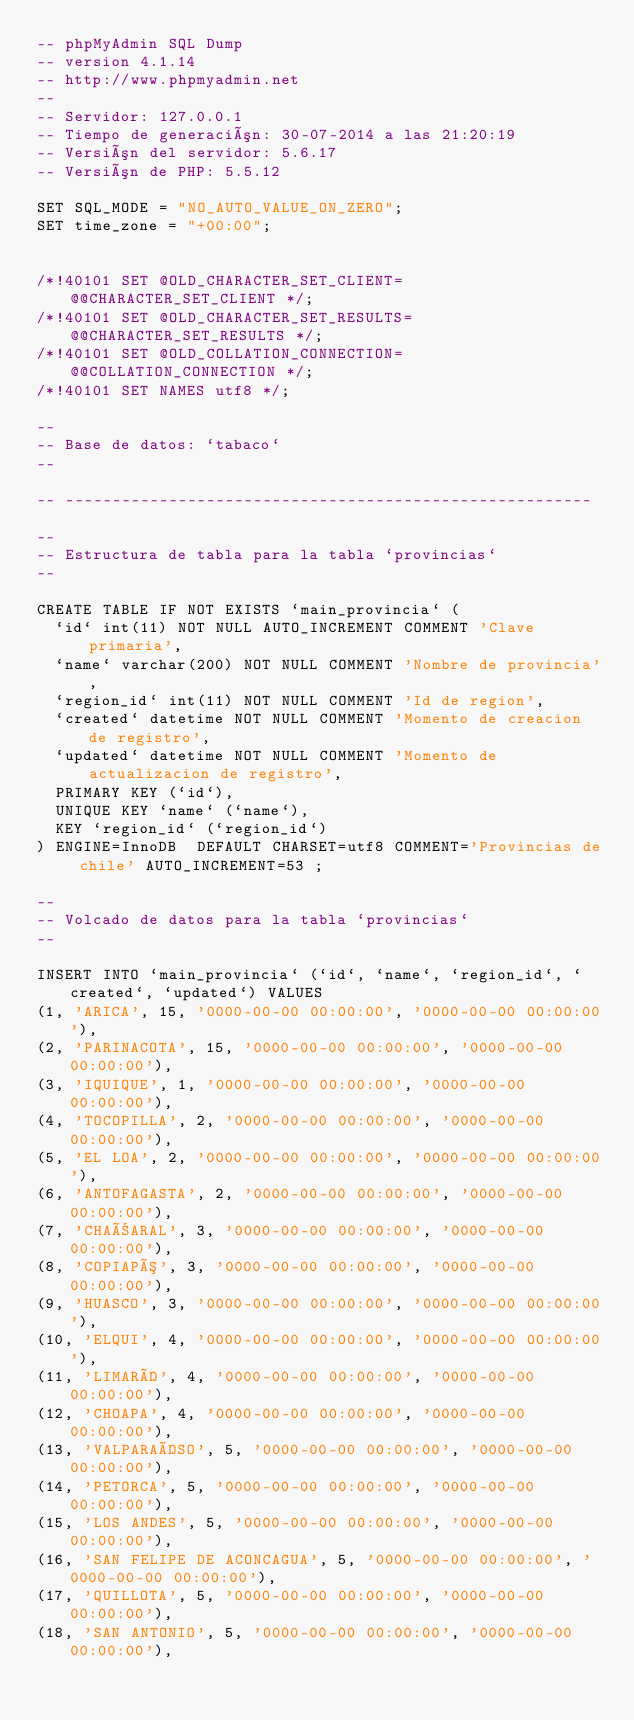Convert code to text. <code><loc_0><loc_0><loc_500><loc_500><_SQL_>-- phpMyAdmin SQL Dump
-- version 4.1.14
-- http://www.phpmyadmin.net
--
-- Servidor: 127.0.0.1
-- Tiempo de generación: 30-07-2014 a las 21:20:19
-- Versión del servidor: 5.6.17
-- Versión de PHP: 5.5.12

SET SQL_MODE = "NO_AUTO_VALUE_ON_ZERO";
SET time_zone = "+00:00";


/*!40101 SET @OLD_CHARACTER_SET_CLIENT=@@CHARACTER_SET_CLIENT */;
/*!40101 SET @OLD_CHARACTER_SET_RESULTS=@@CHARACTER_SET_RESULTS */;
/*!40101 SET @OLD_COLLATION_CONNECTION=@@COLLATION_CONNECTION */;
/*!40101 SET NAMES utf8 */;

--
-- Base de datos: `tabaco`
--

-- --------------------------------------------------------

--
-- Estructura de tabla para la tabla `provincias`
--

CREATE TABLE IF NOT EXISTS `main_provincia` (
  `id` int(11) NOT NULL AUTO_INCREMENT COMMENT 'Clave primaria',
  `name` varchar(200) NOT NULL COMMENT 'Nombre de provincia',
  `region_id` int(11) NOT NULL COMMENT 'Id de region',
  `created` datetime NOT NULL COMMENT 'Momento de creacion de registro',
  `updated` datetime NOT NULL COMMENT 'Momento de actualizacion de registro',
  PRIMARY KEY (`id`),
  UNIQUE KEY `name` (`name`),
  KEY `region_id` (`region_id`)
) ENGINE=InnoDB  DEFAULT CHARSET=utf8 COMMENT='Provincias de chile' AUTO_INCREMENT=53 ;

--
-- Volcado de datos para la tabla `provincias`
--

INSERT INTO `main_provincia` (`id`, `name`, `region_id`, `created`, `updated`) VALUES
(1, 'ARICA', 15, '0000-00-00 00:00:00', '0000-00-00 00:00:00'),
(2, 'PARINACOTA', 15, '0000-00-00 00:00:00', '0000-00-00 00:00:00'),
(3, 'IQUIQUE', 1, '0000-00-00 00:00:00', '0000-00-00 00:00:00'),
(4, 'TOCOPILLA', 2, '0000-00-00 00:00:00', '0000-00-00 00:00:00'),
(5, 'EL LOA', 2, '0000-00-00 00:00:00', '0000-00-00 00:00:00'),
(6, 'ANTOFAGASTA', 2, '0000-00-00 00:00:00', '0000-00-00 00:00:00'),
(7, 'CHAÑARAL', 3, '0000-00-00 00:00:00', '0000-00-00 00:00:00'),
(8, 'COPIAPÓ', 3, '0000-00-00 00:00:00', '0000-00-00 00:00:00'),
(9, 'HUASCO', 3, '0000-00-00 00:00:00', '0000-00-00 00:00:00'),
(10, 'ELQUI', 4, '0000-00-00 00:00:00', '0000-00-00 00:00:00'),
(11, 'LIMARÍ', 4, '0000-00-00 00:00:00', '0000-00-00 00:00:00'),
(12, 'CHOAPA', 4, '0000-00-00 00:00:00', '0000-00-00 00:00:00'),
(13, 'VALPARAÍSO', 5, '0000-00-00 00:00:00', '0000-00-00 00:00:00'),
(14, 'PETORCA', 5, '0000-00-00 00:00:00', '0000-00-00 00:00:00'),
(15, 'LOS ANDES', 5, '0000-00-00 00:00:00', '0000-00-00 00:00:00'),
(16, 'SAN FELIPE DE ACONCAGUA', 5, '0000-00-00 00:00:00', '0000-00-00 00:00:00'),
(17, 'QUILLOTA', 5, '0000-00-00 00:00:00', '0000-00-00 00:00:00'),
(18, 'SAN ANTONIO', 5, '0000-00-00 00:00:00', '0000-00-00 00:00:00'),</code> 